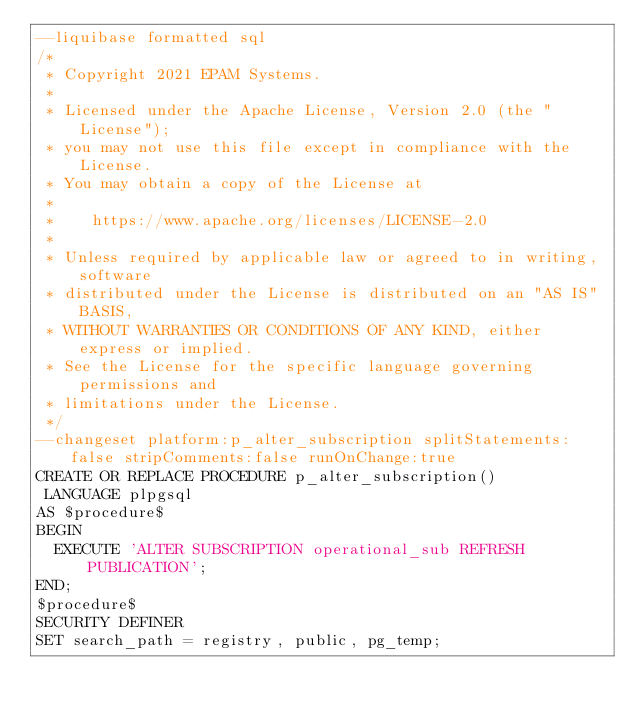Convert code to text. <code><loc_0><loc_0><loc_500><loc_500><_SQL_>--liquibase formatted sql
/*
 * Copyright 2021 EPAM Systems.
 * 
 * Licensed under the Apache License, Version 2.0 (the "License");
 * you may not use this file except in compliance with the License.
 * You may obtain a copy of the License at
 * 
 *    https://www.apache.org/licenses/LICENSE-2.0
 * 
 * Unless required by applicable law or agreed to in writing, software
 * distributed under the License is distributed on an "AS IS" BASIS,
 * WITHOUT WARRANTIES OR CONDITIONS OF ANY KIND, either express or implied.
 * See the License for the specific language governing permissions and
 * limitations under the License.
 */
--changeset platform:p_alter_subscription splitStatements:false stripComments:false runOnChange:true
CREATE OR REPLACE PROCEDURE p_alter_subscription()
 LANGUAGE plpgsql
AS $procedure$
BEGIN
  EXECUTE 'ALTER SUBSCRIPTION operational_sub REFRESH PUBLICATION';
END;
$procedure$
SECURITY DEFINER
SET search_path = registry, public, pg_temp;
</code> 